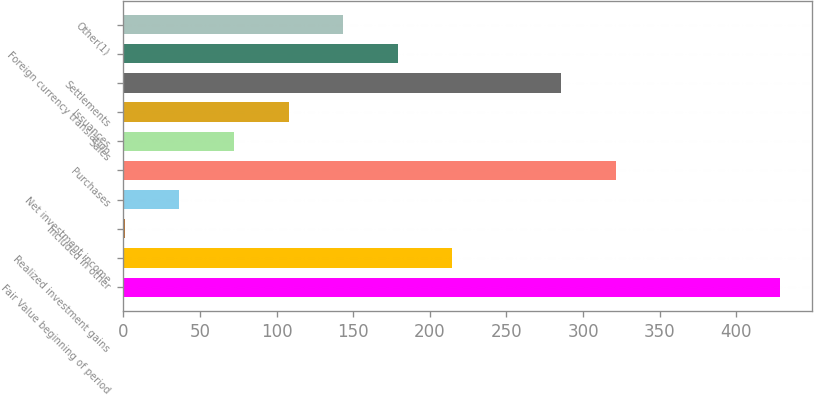Convert chart to OTSL. <chart><loc_0><loc_0><loc_500><loc_500><bar_chart><fcel>Fair Value beginning of period<fcel>Realized investment gains<fcel>Included in other<fcel>Net investment income<fcel>Purchases<fcel>Sales<fcel>Issuances<fcel>Settlements<fcel>Foreign currency translation<fcel>Other(1)<nl><fcel>428.2<fcel>214.6<fcel>1<fcel>36.6<fcel>321.4<fcel>72.2<fcel>107.8<fcel>285.8<fcel>179<fcel>143.4<nl></chart> 